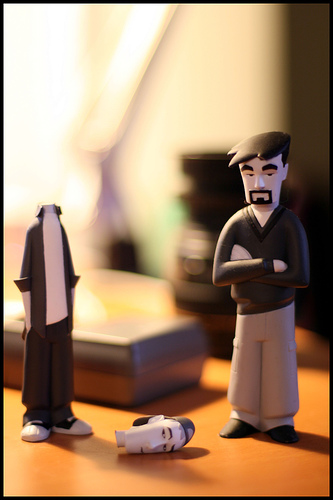<image>
Is there a figurine to the right of the table? No. The figurine is not to the right of the table. The horizontal positioning shows a different relationship. 